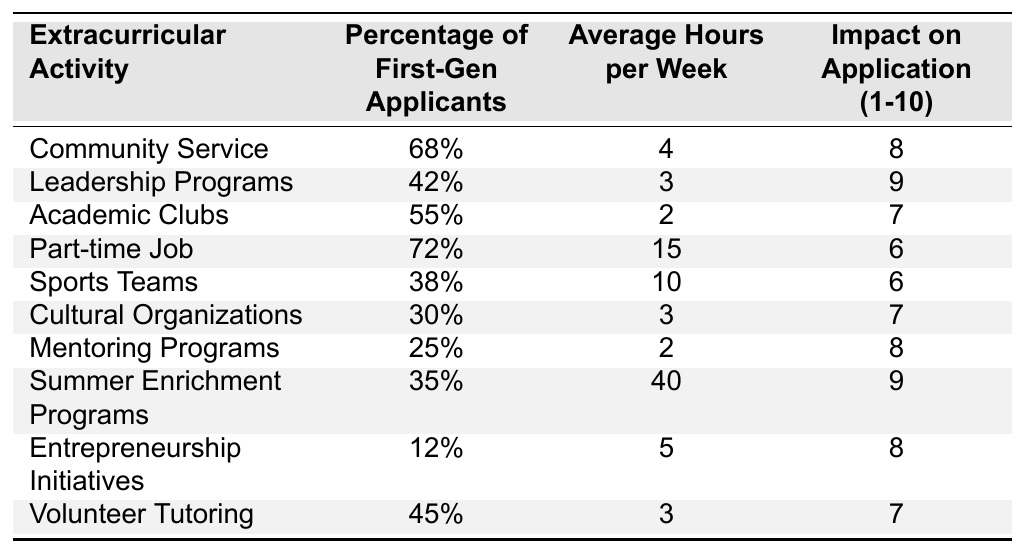What percentage of first-generation applicants participate in Community Service? The table shows that 68% of first-generation applicants are involved in Community Service.
Answer: 68% Which extracurricular activity has the highest average hours per week? According to the table, Summer Enrichment Programs have the highest average hours per week at 40 hours.
Answer: 40 How many first-generation applicants are involved in part-time jobs? The table indicates that 72% of first-generation applicants are involved in part-time jobs.
Answer: 72% What is the average impact score of extracurricular activities listed in the table? To find the average, add all impact scores (8 + 9 + 7 + 6 + 6 + 7 + 8 + 9 + 8 + 7 = 78) and divide by the number of activities (10) giving an average of 7.8.
Answer: 7.8 Is participation in Cultural Organizations above or below 30%? The table states that 30% of first-generation applicants are involved in Cultural Organizations, which means it is exactly at 30%.
Answer: No What is the difference in average hours per week between Sports Teams and Volunteer Tutoring? The average hours for Sports Teams is 10 and for Volunteer Tutoring is 3. The difference is 10 - 3 = 7 hours.
Answer: 7 Which activity has the lowest percentage of participation among first-generation applicants? The table shows that Entrepreneurship Initiatives have the lowest percentage of participation at 12%.
Answer: 12% What is the combined percentage of first-generation applicants involved in Leadership Programs and Academic Clubs? The table shows 42% for Leadership Programs and 55% for Academic Clubs. The combined percentage is 42 + 55 = 97%.
Answer: 97% Which extracurricular activity is linked with the highest impact on an application? Looking at the impact scores, Leadership Programs are the highest at a score of 9.
Answer: 9 Based on the data, what can be inferred about the relationship between average hours spent and impact score? While examining the hours and scores, there isn’t a clear trend; for example, a high impact score (9) aligns with Summer Enrichment Programs (40 hours), while Part-time Jobs (15 hours) have a lower impact (6). Further comparison is needed to determine the relationship.
Answer: No clear relationship 